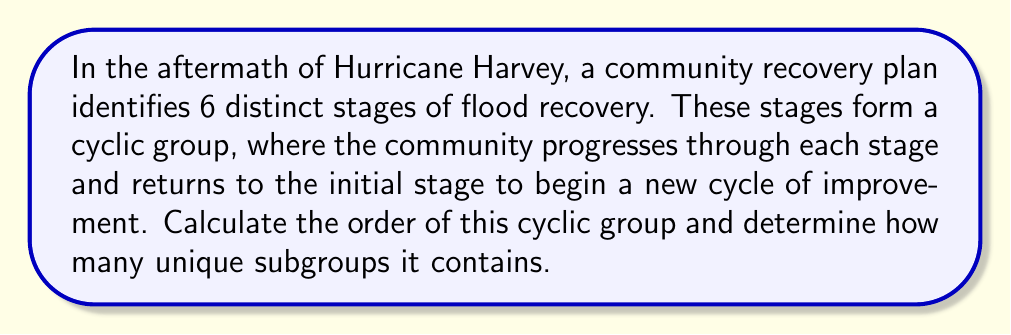Provide a solution to this math problem. To solve this problem, we need to understand the properties of cyclic groups and their subgroups.

1. Order of the cyclic group:
   The order of a cyclic group is equal to the number of elements in the group. In this case, there are 6 distinct stages of flood recovery, so the order of the group is 6.

2. Subgroups of a cyclic group:
   The number of subgroups in a cyclic group is related to the divisors of the group's order. A cyclic group of order $n$ has a subgroup of order $d$ for each divisor $d$ of $n$.

3. Find the divisors of 6:
   The divisors of 6 are 1, 2, 3, and 6.

4. Count the subgroups:
   Each divisor corresponds to a unique subgroup, so the number of subgroups is equal to the number of divisors.

Therefore, the cyclic group representing the flood recovery stages has an order of 6 and contains 4 unique subgroups.

To visualize this, we can represent the cyclic group as:

$$C_6 = \{e, a, a^2, a^3, a^4, a^5\}$$

Where $e$ is the identity element (starting point) and $a$ represents moving to the next stage.

The subgroups are:
- $\{e\}$ (order 1)
- $\{e, a^3\}$ (order 2)
- $\{e, a^2, a^4\}$ (order 3)
- $C_6$ itself (order 6)
Answer: The order of the cyclic group is 6, and it contains 4 unique subgroups. 